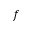<formula> <loc_0><loc_0><loc_500><loc_500>f</formula> 